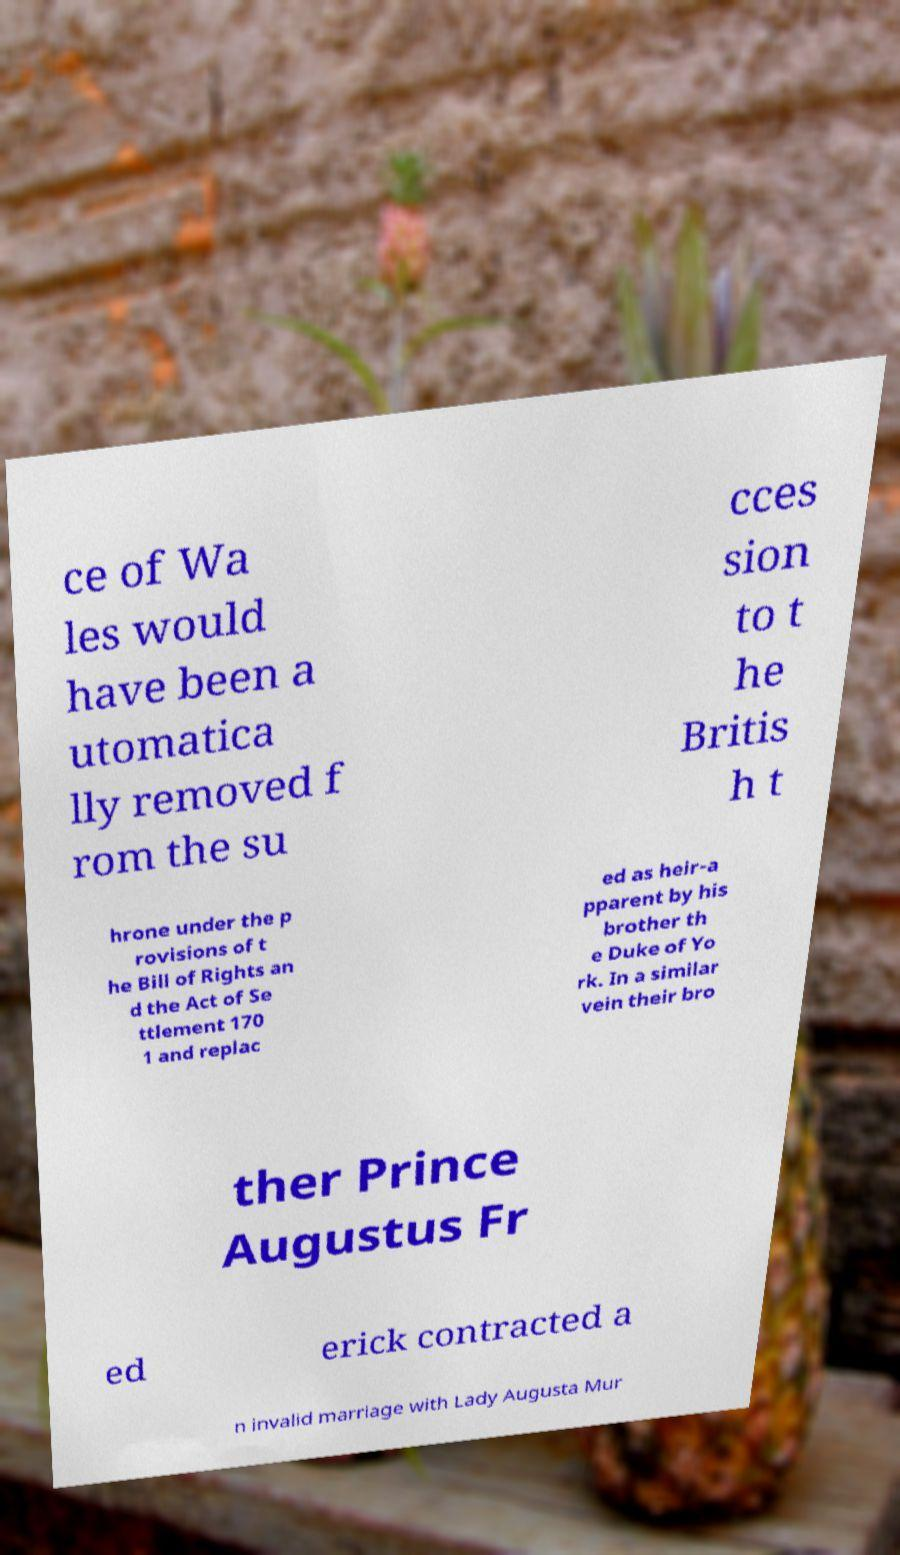There's text embedded in this image that I need extracted. Can you transcribe it verbatim? ce of Wa les would have been a utomatica lly removed f rom the su cces sion to t he Britis h t hrone under the p rovisions of t he Bill of Rights an d the Act of Se ttlement 170 1 and replac ed as heir-a pparent by his brother th e Duke of Yo rk. In a similar vein their bro ther Prince Augustus Fr ed erick contracted a n invalid marriage with Lady Augusta Mur 